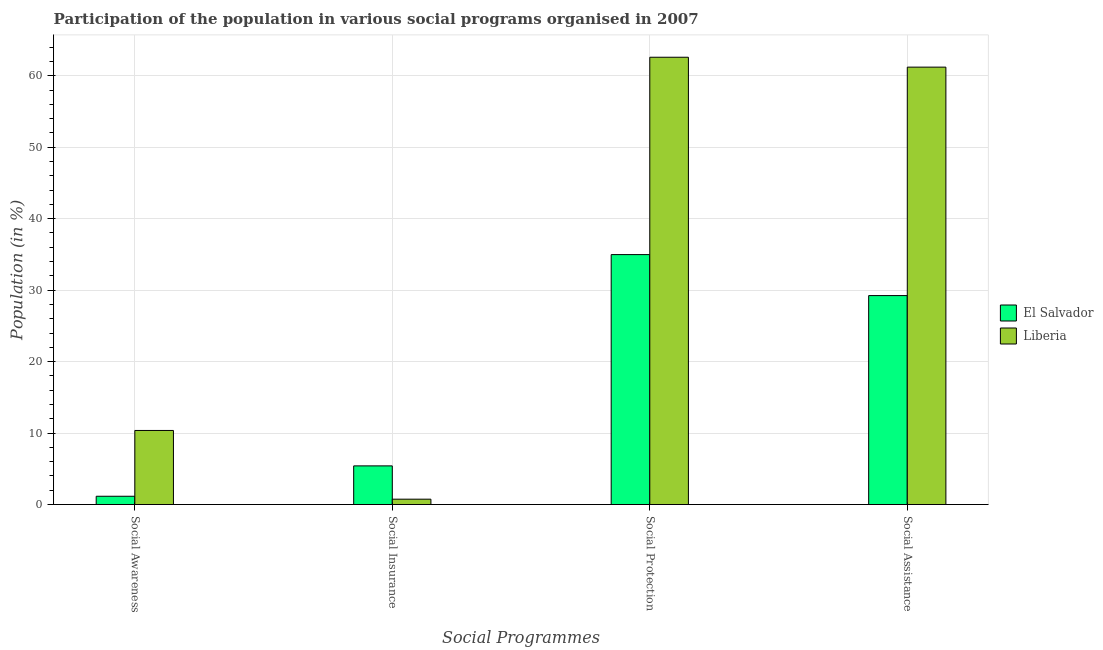How many different coloured bars are there?
Provide a succinct answer. 2. How many groups of bars are there?
Give a very brief answer. 4. Are the number of bars per tick equal to the number of legend labels?
Give a very brief answer. Yes. Are the number of bars on each tick of the X-axis equal?
Your response must be concise. Yes. How many bars are there on the 1st tick from the left?
Offer a terse response. 2. What is the label of the 3rd group of bars from the left?
Your answer should be compact. Social Protection. What is the participation of population in social assistance programs in Liberia?
Your response must be concise. 61.2. Across all countries, what is the maximum participation of population in social insurance programs?
Keep it short and to the point. 5.41. Across all countries, what is the minimum participation of population in social protection programs?
Offer a terse response. 34.97. In which country was the participation of population in social protection programs maximum?
Provide a short and direct response. Liberia. In which country was the participation of population in social insurance programs minimum?
Offer a terse response. Liberia. What is the total participation of population in social protection programs in the graph?
Offer a terse response. 97.56. What is the difference between the participation of population in social awareness programs in El Salvador and that in Liberia?
Give a very brief answer. -9.21. What is the difference between the participation of population in social awareness programs in Liberia and the participation of population in social protection programs in El Salvador?
Provide a succinct answer. -24.61. What is the average participation of population in social awareness programs per country?
Keep it short and to the point. 5.76. What is the difference between the participation of population in social awareness programs and participation of population in social assistance programs in El Salvador?
Offer a terse response. -28.08. What is the ratio of the participation of population in social protection programs in Liberia to that in El Salvador?
Your response must be concise. 1.79. Is the participation of population in social awareness programs in Liberia less than that in El Salvador?
Offer a very short reply. No. What is the difference between the highest and the second highest participation of population in social assistance programs?
Keep it short and to the point. 31.97. What is the difference between the highest and the lowest participation of population in social protection programs?
Your response must be concise. 27.62. What does the 2nd bar from the left in Social Insurance represents?
Provide a succinct answer. Liberia. What does the 2nd bar from the right in Social Awareness represents?
Offer a very short reply. El Salvador. Is it the case that in every country, the sum of the participation of population in social awareness programs and participation of population in social insurance programs is greater than the participation of population in social protection programs?
Your answer should be compact. No. How many bars are there?
Your answer should be very brief. 8. Are all the bars in the graph horizontal?
Your response must be concise. No. Are the values on the major ticks of Y-axis written in scientific E-notation?
Your response must be concise. No. Where does the legend appear in the graph?
Provide a short and direct response. Center right. How many legend labels are there?
Keep it short and to the point. 2. What is the title of the graph?
Your response must be concise. Participation of the population in various social programs organised in 2007. What is the label or title of the X-axis?
Keep it short and to the point. Social Programmes. What is the Population (in %) in El Salvador in Social Awareness?
Make the answer very short. 1.16. What is the Population (in %) of Liberia in Social Awareness?
Provide a succinct answer. 10.37. What is the Population (in %) in El Salvador in Social Insurance?
Offer a very short reply. 5.41. What is the Population (in %) of Liberia in Social Insurance?
Provide a short and direct response. 0.75. What is the Population (in %) of El Salvador in Social Protection?
Your answer should be very brief. 34.97. What is the Population (in %) in Liberia in Social Protection?
Your answer should be very brief. 62.59. What is the Population (in %) in El Salvador in Social Assistance?
Provide a short and direct response. 29.24. What is the Population (in %) of Liberia in Social Assistance?
Keep it short and to the point. 61.2. Across all Social Programmes, what is the maximum Population (in %) in El Salvador?
Your response must be concise. 34.97. Across all Social Programmes, what is the maximum Population (in %) in Liberia?
Your response must be concise. 62.59. Across all Social Programmes, what is the minimum Population (in %) of El Salvador?
Give a very brief answer. 1.16. Across all Social Programmes, what is the minimum Population (in %) of Liberia?
Make the answer very short. 0.75. What is the total Population (in %) of El Salvador in the graph?
Provide a short and direct response. 70.78. What is the total Population (in %) of Liberia in the graph?
Ensure brevity in your answer.  134.91. What is the difference between the Population (in %) in El Salvador in Social Awareness and that in Social Insurance?
Make the answer very short. -4.25. What is the difference between the Population (in %) in Liberia in Social Awareness and that in Social Insurance?
Provide a succinct answer. 9.62. What is the difference between the Population (in %) in El Salvador in Social Awareness and that in Social Protection?
Give a very brief answer. -33.81. What is the difference between the Population (in %) in Liberia in Social Awareness and that in Social Protection?
Offer a terse response. -52.22. What is the difference between the Population (in %) of El Salvador in Social Awareness and that in Social Assistance?
Your answer should be compact. -28.08. What is the difference between the Population (in %) in Liberia in Social Awareness and that in Social Assistance?
Offer a very short reply. -50.84. What is the difference between the Population (in %) of El Salvador in Social Insurance and that in Social Protection?
Make the answer very short. -29.56. What is the difference between the Population (in %) of Liberia in Social Insurance and that in Social Protection?
Your response must be concise. -61.84. What is the difference between the Population (in %) of El Salvador in Social Insurance and that in Social Assistance?
Offer a terse response. -23.83. What is the difference between the Population (in %) of Liberia in Social Insurance and that in Social Assistance?
Your response must be concise. -60.46. What is the difference between the Population (in %) of El Salvador in Social Protection and that in Social Assistance?
Offer a very short reply. 5.74. What is the difference between the Population (in %) of Liberia in Social Protection and that in Social Assistance?
Your response must be concise. 1.38. What is the difference between the Population (in %) in El Salvador in Social Awareness and the Population (in %) in Liberia in Social Insurance?
Make the answer very short. 0.41. What is the difference between the Population (in %) in El Salvador in Social Awareness and the Population (in %) in Liberia in Social Protection?
Give a very brief answer. -61.43. What is the difference between the Population (in %) of El Salvador in Social Awareness and the Population (in %) of Liberia in Social Assistance?
Your answer should be compact. -60.05. What is the difference between the Population (in %) in El Salvador in Social Insurance and the Population (in %) in Liberia in Social Protection?
Make the answer very short. -57.18. What is the difference between the Population (in %) of El Salvador in Social Insurance and the Population (in %) of Liberia in Social Assistance?
Provide a short and direct response. -55.8. What is the difference between the Population (in %) of El Salvador in Social Protection and the Population (in %) of Liberia in Social Assistance?
Provide a short and direct response. -26.23. What is the average Population (in %) in El Salvador per Social Programmes?
Provide a short and direct response. 17.69. What is the average Population (in %) of Liberia per Social Programmes?
Offer a terse response. 33.73. What is the difference between the Population (in %) of El Salvador and Population (in %) of Liberia in Social Awareness?
Your answer should be very brief. -9.21. What is the difference between the Population (in %) of El Salvador and Population (in %) of Liberia in Social Insurance?
Your answer should be compact. 4.66. What is the difference between the Population (in %) of El Salvador and Population (in %) of Liberia in Social Protection?
Offer a very short reply. -27.62. What is the difference between the Population (in %) in El Salvador and Population (in %) in Liberia in Social Assistance?
Offer a very short reply. -31.97. What is the ratio of the Population (in %) in El Salvador in Social Awareness to that in Social Insurance?
Make the answer very short. 0.21. What is the ratio of the Population (in %) in Liberia in Social Awareness to that in Social Insurance?
Offer a terse response. 13.83. What is the ratio of the Population (in %) of El Salvador in Social Awareness to that in Social Protection?
Make the answer very short. 0.03. What is the ratio of the Population (in %) in Liberia in Social Awareness to that in Social Protection?
Give a very brief answer. 0.17. What is the ratio of the Population (in %) of El Salvador in Social Awareness to that in Social Assistance?
Your answer should be compact. 0.04. What is the ratio of the Population (in %) of Liberia in Social Awareness to that in Social Assistance?
Keep it short and to the point. 0.17. What is the ratio of the Population (in %) of El Salvador in Social Insurance to that in Social Protection?
Provide a short and direct response. 0.15. What is the ratio of the Population (in %) in Liberia in Social Insurance to that in Social Protection?
Offer a very short reply. 0.01. What is the ratio of the Population (in %) of El Salvador in Social Insurance to that in Social Assistance?
Give a very brief answer. 0.18. What is the ratio of the Population (in %) in Liberia in Social Insurance to that in Social Assistance?
Make the answer very short. 0.01. What is the ratio of the Population (in %) in El Salvador in Social Protection to that in Social Assistance?
Offer a terse response. 1.2. What is the ratio of the Population (in %) in Liberia in Social Protection to that in Social Assistance?
Keep it short and to the point. 1.02. What is the difference between the highest and the second highest Population (in %) of El Salvador?
Provide a short and direct response. 5.74. What is the difference between the highest and the second highest Population (in %) of Liberia?
Your response must be concise. 1.38. What is the difference between the highest and the lowest Population (in %) in El Salvador?
Provide a short and direct response. 33.81. What is the difference between the highest and the lowest Population (in %) in Liberia?
Give a very brief answer. 61.84. 